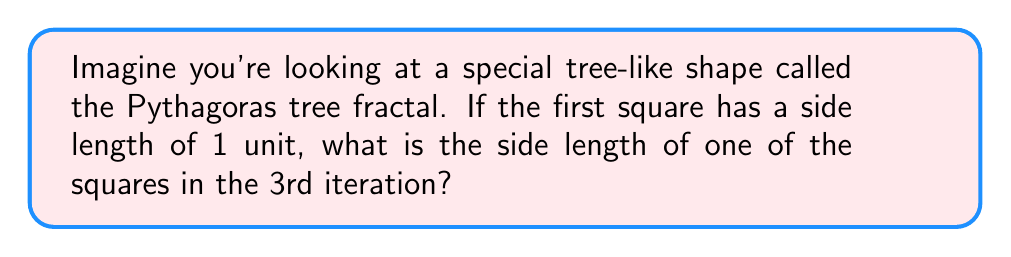Help me with this question. Let's break this down step-by-step:

1) In the Pythagoras tree fractal, each iteration creates two new squares on top of the previous square.

2) The side length of each new square is related to the side length of the previous square by the formula:

   $$ \text{new side length} = \frac{\text{previous side length}}{\sqrt{2}} $$

3) Starting with the first square:
   - 1st iteration: side length = 1

4) For the 2nd iteration:
   $$ \text{side length} = \frac{1}{\sqrt{2}} $$

5) For the 3rd iteration:
   $$ \text{side length} = \frac{1}{\sqrt{2}} \cdot \frac{1}{\sqrt{2}} = \frac{1}{2} $$

6) We can simplify this calculation by noting that each iteration divides the side length by $\sqrt{2}$. So after n iterations, the side length is:

   $$ \text{side length} = \frac{1}{(\sqrt{2})^n} $$

7) For the 3rd iteration, n = 2, so:
   $$ \text{side length} = \frac{1}{(\sqrt{2})^2} = \frac{1}{2} $$
Answer: $\frac{1}{2}$ 